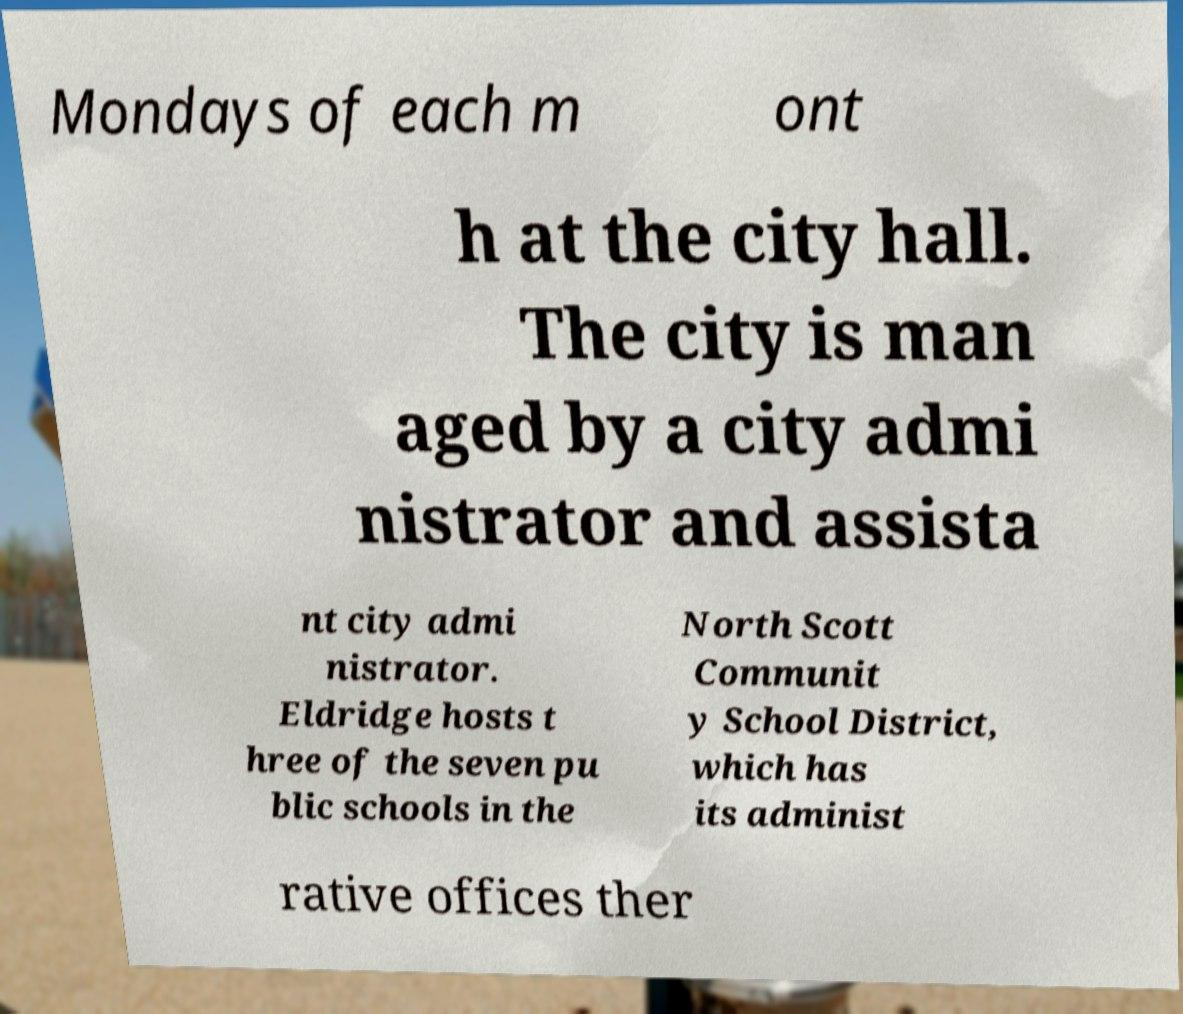Could you assist in decoding the text presented in this image and type it out clearly? Mondays of each m ont h at the city hall. The city is man aged by a city admi nistrator and assista nt city admi nistrator. Eldridge hosts t hree of the seven pu blic schools in the North Scott Communit y School District, which has its administ rative offices ther 